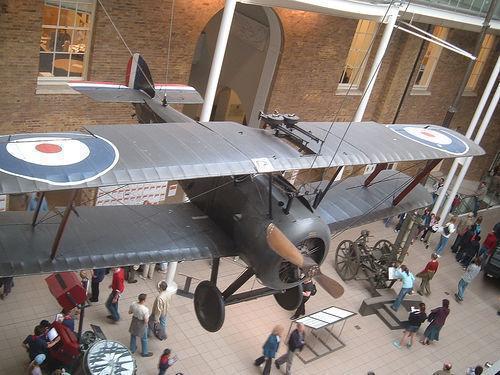What does this building house?
Select the accurate response from the four choices given to answer the question.
Options: Candy shop, airport, museum, train depot. Museum. 